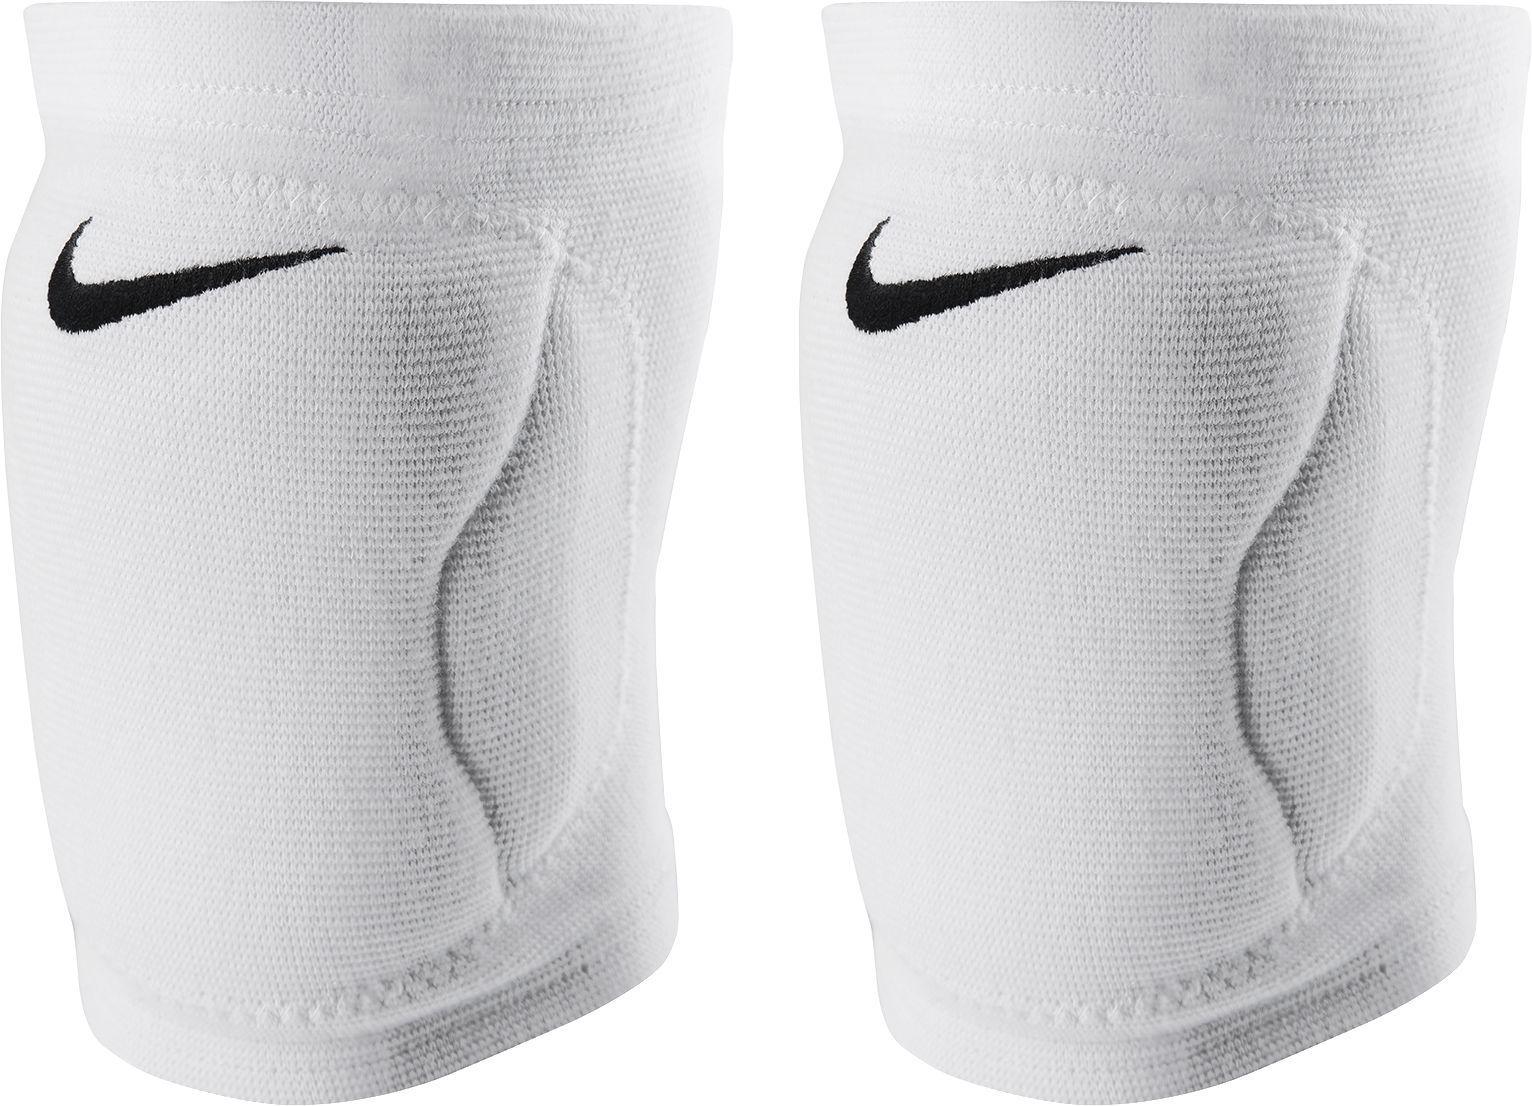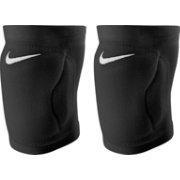The first image is the image on the left, the second image is the image on the right. Analyze the images presented: Is the assertion "There are both black and white knee pads" valid? Answer yes or no. Yes. The first image is the image on the left, the second image is the image on the right. Given the left and right images, does the statement "At least one white knee brace with black logo is shown in one image." hold true? Answer yes or no. Yes. The first image is the image on the left, the second image is the image on the right. Considering the images on both sides, is "One of the paired images contains one black brace and one white brace." valid? Answer yes or no. No. The first image is the image on the left, the second image is the image on the right. Given the left and right images, does the statement "Each image shows a pair of knee wraps." hold true? Answer yes or no. Yes. 